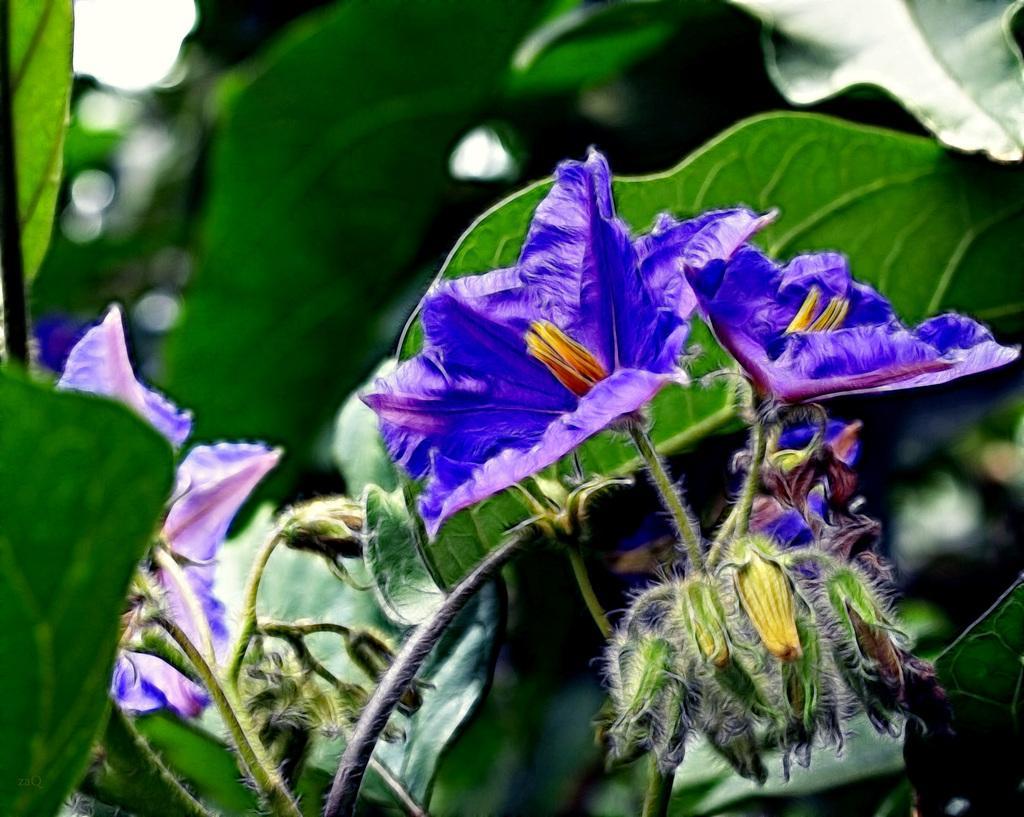Could you give a brief overview of what you see in this image? In this image we can see flowers to the plants. 